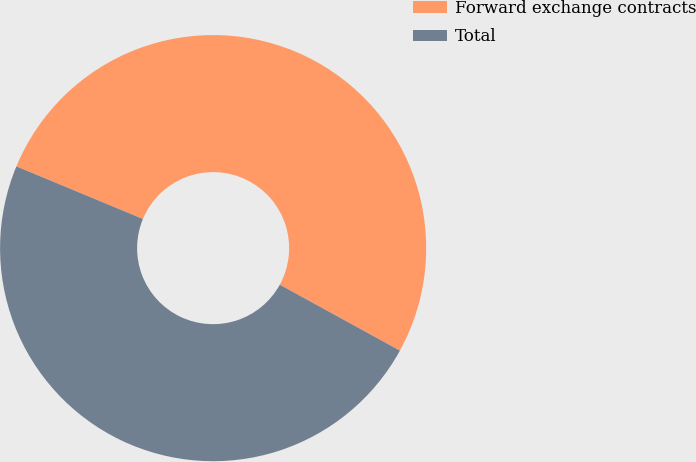Convert chart to OTSL. <chart><loc_0><loc_0><loc_500><loc_500><pie_chart><fcel>Forward exchange contracts<fcel>Total<nl><fcel>51.72%<fcel>48.28%<nl></chart> 